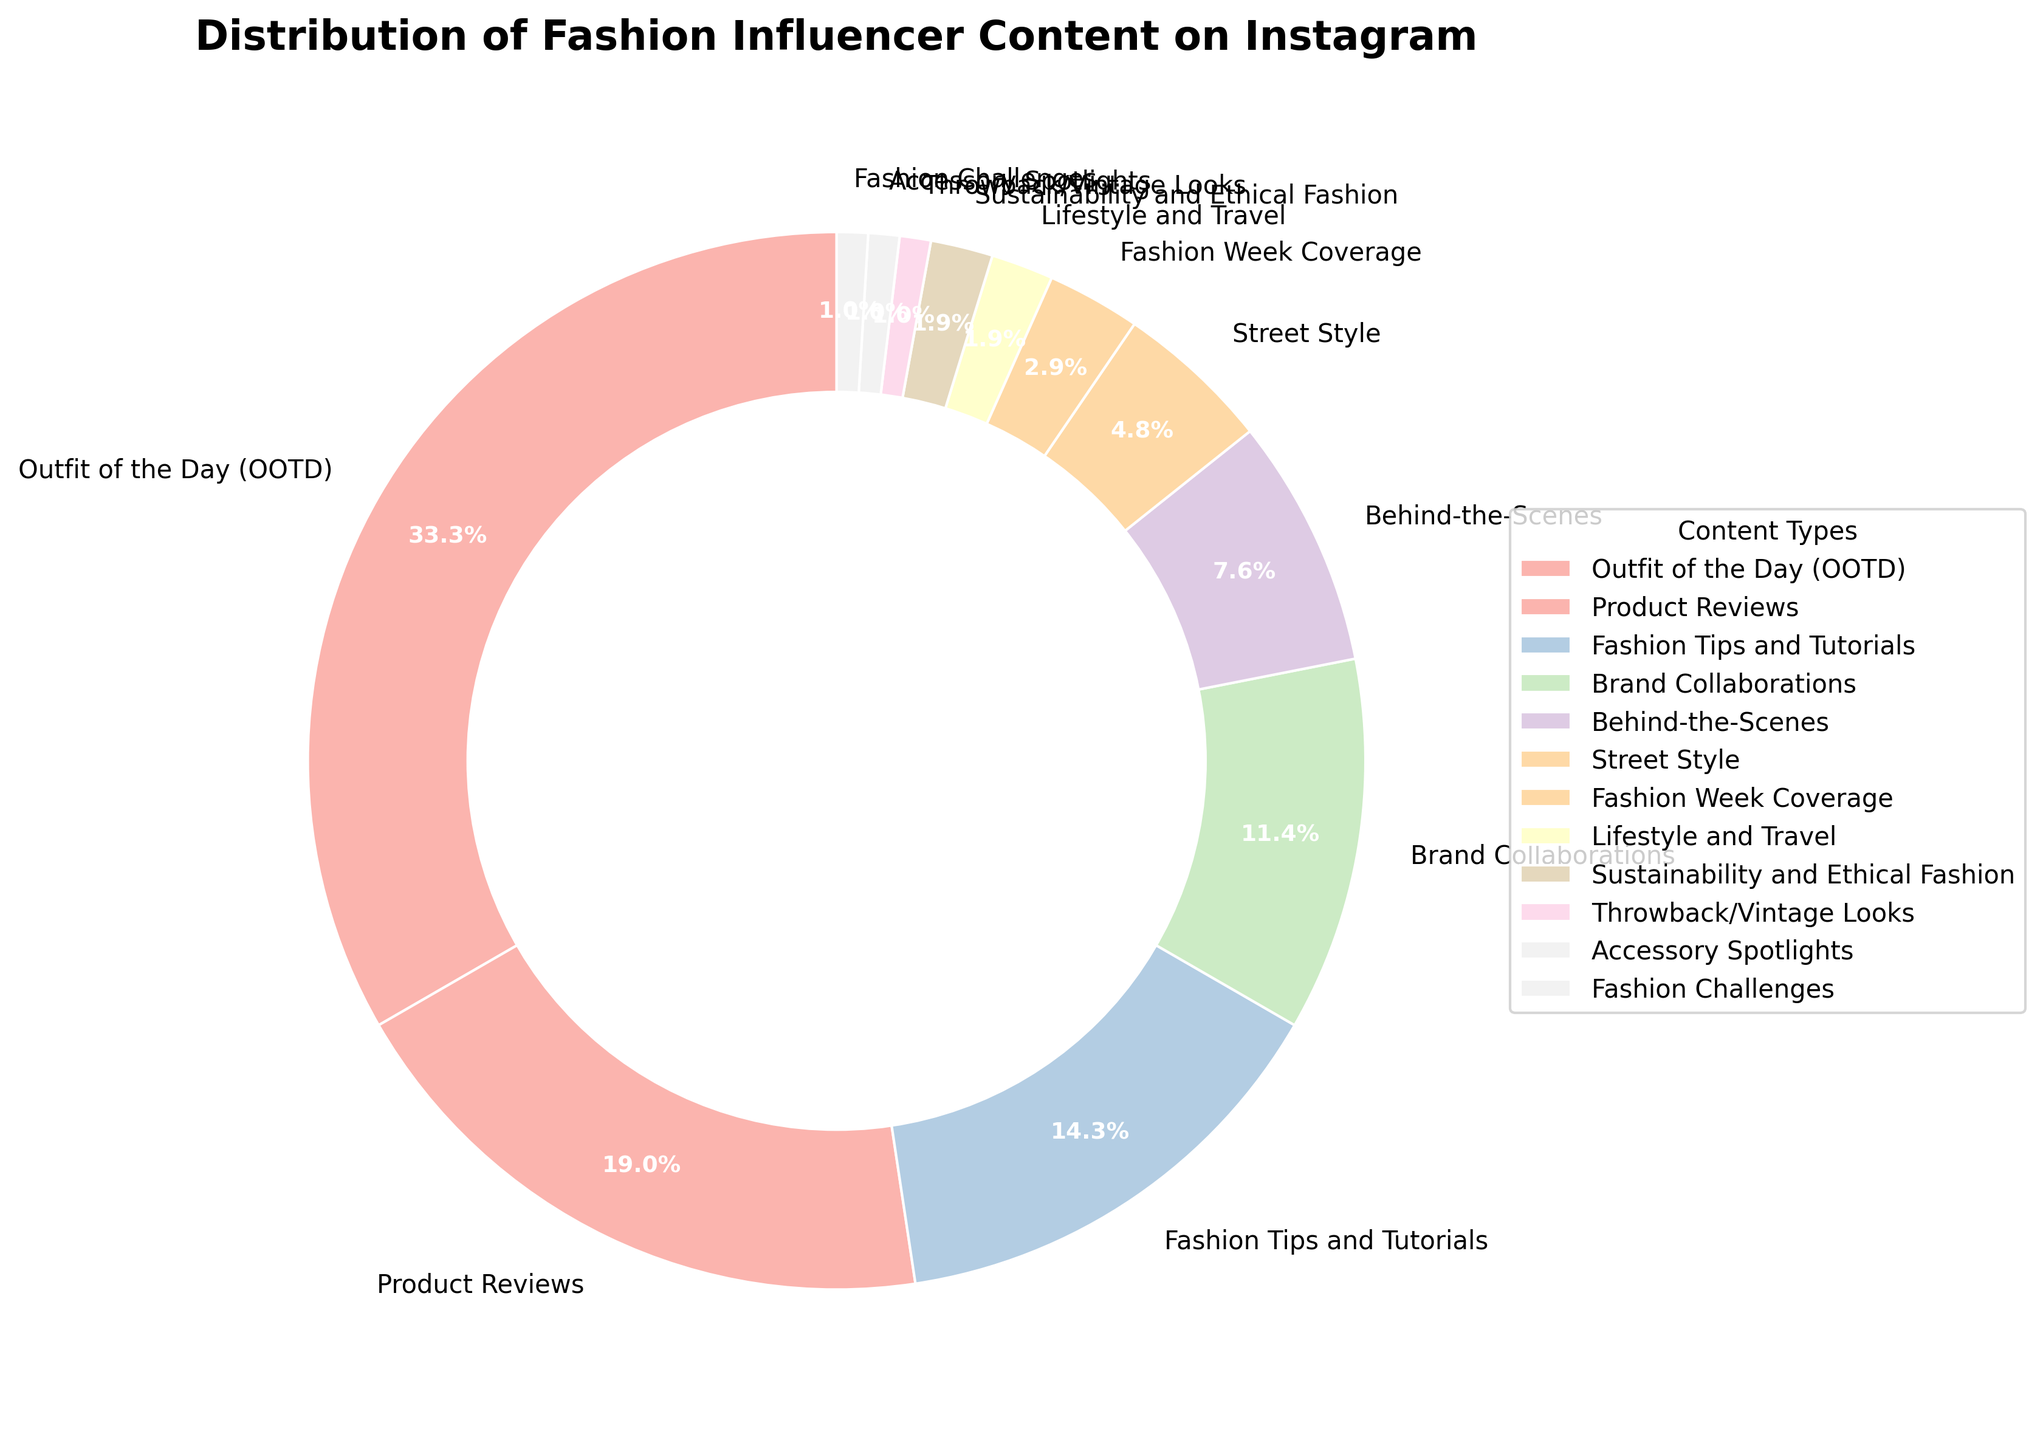Which content type has the highest percentage? The pie chart shows the distribution of percentages for various content types. The segment labeled "Outfit of the Day (OOTD)" has the highest percentage at 35%.
Answer: Outfit of the Day (OOTD) How much more percentage does "Outfit of the Day (OOTD)" have compared to "Product Reviews"? "Outfit of the Day (OOTD)" has a percentage of 35%, and "Product Reviews" has 20%. The difference is 35 - 20 = 15%.
Answer: 15% Which two categories have the least percentage, and what is their combined total? The pie chart shows that "Throwback/Vintage Looks" and "Accessory Spotlights" both have 1%. Their combined total is 1 + 1 = 2%.
Answer: Throwback/Vintage Looks and Accessory Spotlights, 2% What is the combined percentage of "Fashion Tips and Tutorials" and "Brand Collaborations"? "Fashion Tips and Tutorials" is 15%, and "Brand Collaborations" is 12%. Their combined percentage is 15 + 12 = 27%.
Answer: 27% Is the percentage of "Behind-the-Scenes" content greater than "Street Style" content? "Behind-the-Scenes" has a percentage of 8%, and "Street Style" has a percentage of 5%. Therefore, 8% is greater than 5%.
Answer: Yes How do the percentages for "Sustainability and Ethical Fashion" and "Lifestyle and Travel" compare? Both "Sustainability and Ethical Fashion" and "Lifestyle and Travel" have the same percentage of 2%.
Answer: They are equal Which content type occupies the largest segment visually? The pie chart shows that "Outfit of the Day (OOTD)" has the largest segment, indicating it has the highest percentage.
Answer: Outfit of the Day (OOTD) Calculate the percentage contribution of all content types that have less than 10%. The content types with less than 10% are "Behind-the-Scenes" (8%), "Street Style" (5%), "Fashion Week Coverage" (3%), "Lifestyle and Travel" (2%), "Sustainability and Ethical Fashion" (2%), "Throwback/Vintage Looks" (1%), "Accessory Spotlights" (1%), and "Fashion Challenges" (1%). Adding these together: 8 + 5 + 3 + 2 + 2 + 1 + 1 + 1 = 23%.
Answer: 23% Identify all content types that collectively make up more than 50% of the chart. The content types and their percentages are "Outfit of the Day (OOTD)" (35%) and "Product Reviews" (20%). Adding these together: 35 + 20 = 55%. Therefore, the collective percentage is above 50%.
Answer: Outfit of the Day (OOTD) and Product Reviews 